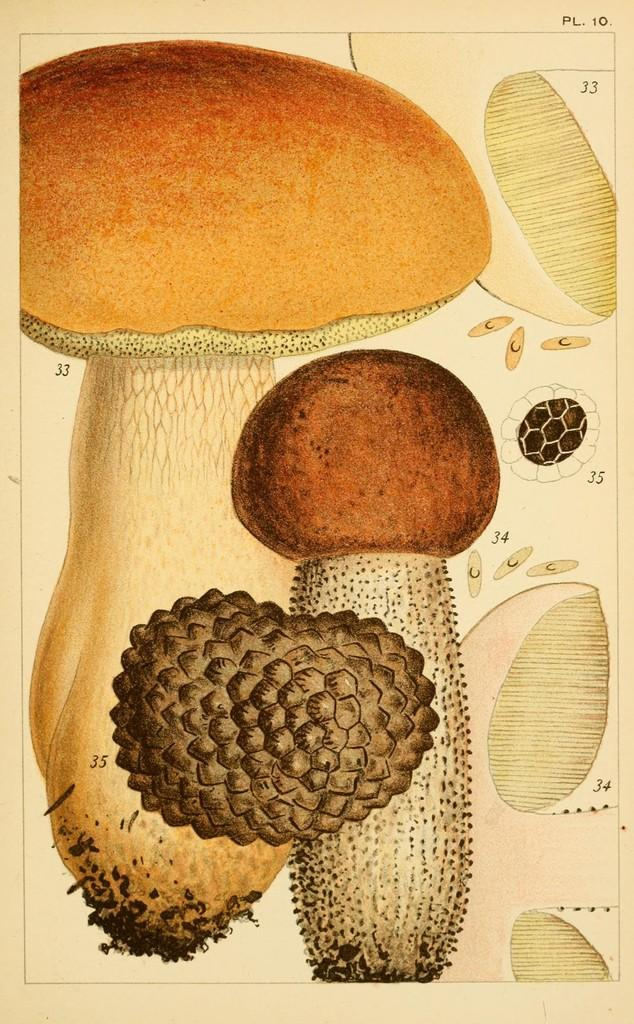What is depicted in the image? The image contains a sketch of a picture. What is the main subject of the sketch? There are mushrooms in the sketch. Are there any additional details related to mushrooms in the sketch? Yes, there are parts of a mushroom on the side of the sketch. What type of sofa can be seen in the sketch? There is no sofa present in the sketch; it features mushrooms and parts of a mushroom. Can you describe the play that is happening in the sketch? There is no play depicted in the sketch; it is a static image of mushrooms and parts of a mushroom. 